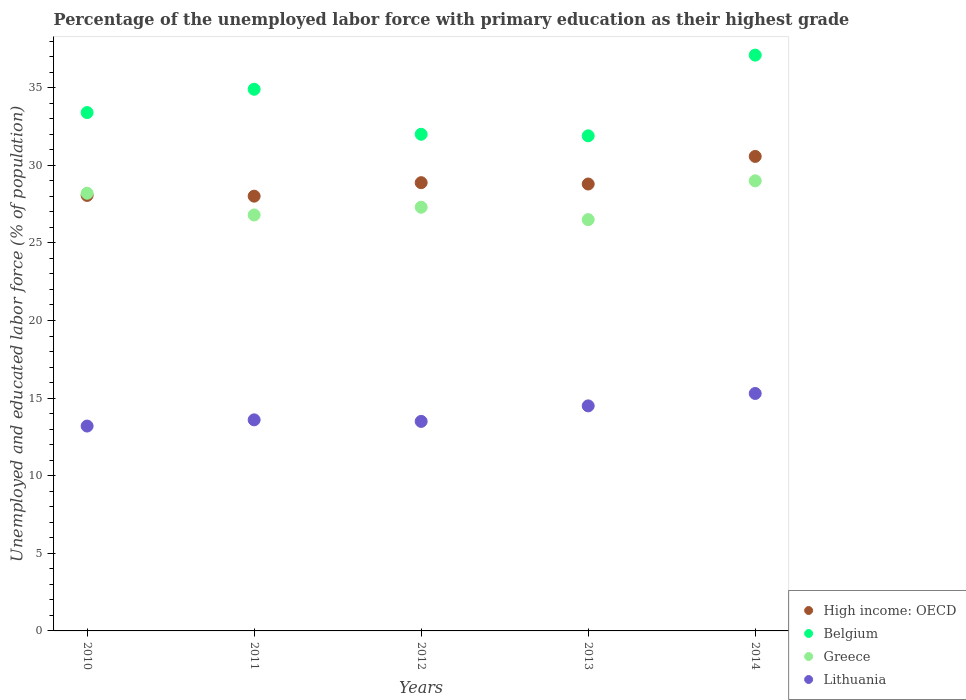What is the percentage of the unemployed labor force with primary education in Lithuania in 2010?
Make the answer very short. 13.2. Across all years, what is the maximum percentage of the unemployed labor force with primary education in Lithuania?
Your answer should be very brief. 15.3. Across all years, what is the minimum percentage of the unemployed labor force with primary education in Belgium?
Ensure brevity in your answer.  31.9. What is the total percentage of the unemployed labor force with primary education in Belgium in the graph?
Provide a short and direct response. 169.3. What is the difference between the percentage of the unemployed labor force with primary education in Greece in 2012 and the percentage of the unemployed labor force with primary education in Lithuania in 2010?
Provide a short and direct response. 14.1. What is the average percentage of the unemployed labor force with primary education in Lithuania per year?
Your response must be concise. 14.02. In the year 2011, what is the difference between the percentage of the unemployed labor force with primary education in Lithuania and percentage of the unemployed labor force with primary education in High income: OECD?
Give a very brief answer. -14.41. What is the ratio of the percentage of the unemployed labor force with primary education in Greece in 2010 to that in 2013?
Keep it short and to the point. 1.06. Is the percentage of the unemployed labor force with primary education in High income: OECD in 2012 less than that in 2013?
Ensure brevity in your answer.  No. What is the difference between the highest and the second highest percentage of the unemployed labor force with primary education in Lithuania?
Provide a succinct answer. 0.8. What is the difference between the highest and the lowest percentage of the unemployed labor force with primary education in Belgium?
Make the answer very short. 5.2. Is it the case that in every year, the sum of the percentage of the unemployed labor force with primary education in High income: OECD and percentage of the unemployed labor force with primary education in Lithuania  is greater than the sum of percentage of the unemployed labor force with primary education in Greece and percentage of the unemployed labor force with primary education in Belgium?
Make the answer very short. No. Is the percentage of the unemployed labor force with primary education in Greece strictly greater than the percentage of the unemployed labor force with primary education in High income: OECD over the years?
Make the answer very short. No. Is the percentage of the unemployed labor force with primary education in Lithuania strictly less than the percentage of the unemployed labor force with primary education in Greece over the years?
Provide a succinct answer. Yes. How many dotlines are there?
Keep it short and to the point. 4. How many years are there in the graph?
Ensure brevity in your answer.  5. Are the values on the major ticks of Y-axis written in scientific E-notation?
Your response must be concise. No. Does the graph contain any zero values?
Your response must be concise. No. Does the graph contain grids?
Keep it short and to the point. No. Where does the legend appear in the graph?
Make the answer very short. Bottom right. How are the legend labels stacked?
Offer a very short reply. Vertical. What is the title of the graph?
Offer a terse response. Percentage of the unemployed labor force with primary education as their highest grade. Does "Bangladesh" appear as one of the legend labels in the graph?
Give a very brief answer. No. What is the label or title of the X-axis?
Offer a very short reply. Years. What is the label or title of the Y-axis?
Offer a very short reply. Unemployed and educated labor force (% of population). What is the Unemployed and educated labor force (% of population) in High income: OECD in 2010?
Ensure brevity in your answer.  28.06. What is the Unemployed and educated labor force (% of population) of Belgium in 2010?
Offer a very short reply. 33.4. What is the Unemployed and educated labor force (% of population) of Greece in 2010?
Make the answer very short. 28.2. What is the Unemployed and educated labor force (% of population) in Lithuania in 2010?
Offer a very short reply. 13.2. What is the Unemployed and educated labor force (% of population) in High income: OECD in 2011?
Your answer should be compact. 28.01. What is the Unemployed and educated labor force (% of population) of Belgium in 2011?
Give a very brief answer. 34.9. What is the Unemployed and educated labor force (% of population) in Greece in 2011?
Give a very brief answer. 26.8. What is the Unemployed and educated labor force (% of population) of Lithuania in 2011?
Make the answer very short. 13.6. What is the Unemployed and educated labor force (% of population) in High income: OECD in 2012?
Give a very brief answer. 28.88. What is the Unemployed and educated labor force (% of population) in Greece in 2012?
Give a very brief answer. 27.3. What is the Unemployed and educated labor force (% of population) of Lithuania in 2012?
Offer a terse response. 13.5. What is the Unemployed and educated labor force (% of population) of High income: OECD in 2013?
Make the answer very short. 28.8. What is the Unemployed and educated labor force (% of population) in Belgium in 2013?
Your answer should be very brief. 31.9. What is the Unemployed and educated labor force (% of population) of Greece in 2013?
Your answer should be very brief. 26.5. What is the Unemployed and educated labor force (% of population) of High income: OECD in 2014?
Provide a short and direct response. 30.57. What is the Unemployed and educated labor force (% of population) of Belgium in 2014?
Ensure brevity in your answer.  37.1. What is the Unemployed and educated labor force (% of population) in Greece in 2014?
Your answer should be very brief. 29. What is the Unemployed and educated labor force (% of population) in Lithuania in 2014?
Ensure brevity in your answer.  15.3. Across all years, what is the maximum Unemployed and educated labor force (% of population) in High income: OECD?
Your response must be concise. 30.57. Across all years, what is the maximum Unemployed and educated labor force (% of population) in Belgium?
Your answer should be very brief. 37.1. Across all years, what is the maximum Unemployed and educated labor force (% of population) of Lithuania?
Offer a terse response. 15.3. Across all years, what is the minimum Unemployed and educated labor force (% of population) of High income: OECD?
Your answer should be very brief. 28.01. Across all years, what is the minimum Unemployed and educated labor force (% of population) in Belgium?
Your answer should be compact. 31.9. Across all years, what is the minimum Unemployed and educated labor force (% of population) of Lithuania?
Keep it short and to the point. 13.2. What is the total Unemployed and educated labor force (% of population) of High income: OECD in the graph?
Make the answer very short. 144.32. What is the total Unemployed and educated labor force (% of population) of Belgium in the graph?
Offer a very short reply. 169.3. What is the total Unemployed and educated labor force (% of population) in Greece in the graph?
Offer a very short reply. 137.8. What is the total Unemployed and educated labor force (% of population) in Lithuania in the graph?
Your answer should be compact. 70.1. What is the difference between the Unemployed and educated labor force (% of population) of High income: OECD in 2010 and that in 2011?
Make the answer very short. 0.05. What is the difference between the Unemployed and educated labor force (% of population) of Belgium in 2010 and that in 2011?
Offer a very short reply. -1.5. What is the difference between the Unemployed and educated labor force (% of population) of Greece in 2010 and that in 2011?
Your answer should be very brief. 1.4. What is the difference between the Unemployed and educated labor force (% of population) in Lithuania in 2010 and that in 2011?
Ensure brevity in your answer.  -0.4. What is the difference between the Unemployed and educated labor force (% of population) in High income: OECD in 2010 and that in 2012?
Make the answer very short. -0.82. What is the difference between the Unemployed and educated labor force (% of population) in Belgium in 2010 and that in 2012?
Provide a short and direct response. 1.4. What is the difference between the Unemployed and educated labor force (% of population) of Greece in 2010 and that in 2012?
Your answer should be very brief. 0.9. What is the difference between the Unemployed and educated labor force (% of population) in Lithuania in 2010 and that in 2012?
Offer a very short reply. -0.3. What is the difference between the Unemployed and educated labor force (% of population) in High income: OECD in 2010 and that in 2013?
Offer a very short reply. -0.74. What is the difference between the Unemployed and educated labor force (% of population) in Belgium in 2010 and that in 2013?
Your answer should be compact. 1.5. What is the difference between the Unemployed and educated labor force (% of population) of Lithuania in 2010 and that in 2013?
Offer a very short reply. -1.3. What is the difference between the Unemployed and educated labor force (% of population) in High income: OECD in 2010 and that in 2014?
Your answer should be compact. -2.51. What is the difference between the Unemployed and educated labor force (% of population) in Belgium in 2010 and that in 2014?
Provide a short and direct response. -3.7. What is the difference between the Unemployed and educated labor force (% of population) of Greece in 2010 and that in 2014?
Keep it short and to the point. -0.8. What is the difference between the Unemployed and educated labor force (% of population) in Lithuania in 2010 and that in 2014?
Your answer should be compact. -2.1. What is the difference between the Unemployed and educated labor force (% of population) in High income: OECD in 2011 and that in 2012?
Make the answer very short. -0.87. What is the difference between the Unemployed and educated labor force (% of population) of Belgium in 2011 and that in 2012?
Your answer should be very brief. 2.9. What is the difference between the Unemployed and educated labor force (% of population) in Greece in 2011 and that in 2012?
Your answer should be very brief. -0.5. What is the difference between the Unemployed and educated labor force (% of population) of Lithuania in 2011 and that in 2012?
Offer a very short reply. 0.1. What is the difference between the Unemployed and educated labor force (% of population) of High income: OECD in 2011 and that in 2013?
Your response must be concise. -0.78. What is the difference between the Unemployed and educated labor force (% of population) of Belgium in 2011 and that in 2013?
Provide a short and direct response. 3. What is the difference between the Unemployed and educated labor force (% of population) in High income: OECD in 2011 and that in 2014?
Offer a very short reply. -2.56. What is the difference between the Unemployed and educated labor force (% of population) in Belgium in 2011 and that in 2014?
Provide a succinct answer. -2.2. What is the difference between the Unemployed and educated labor force (% of population) in Lithuania in 2011 and that in 2014?
Your answer should be very brief. -1.7. What is the difference between the Unemployed and educated labor force (% of population) of High income: OECD in 2012 and that in 2013?
Provide a short and direct response. 0.09. What is the difference between the Unemployed and educated labor force (% of population) in Belgium in 2012 and that in 2013?
Offer a very short reply. 0.1. What is the difference between the Unemployed and educated labor force (% of population) in Greece in 2012 and that in 2013?
Your answer should be compact. 0.8. What is the difference between the Unemployed and educated labor force (% of population) in High income: OECD in 2012 and that in 2014?
Provide a succinct answer. -1.69. What is the difference between the Unemployed and educated labor force (% of population) in Greece in 2012 and that in 2014?
Give a very brief answer. -1.7. What is the difference between the Unemployed and educated labor force (% of population) in High income: OECD in 2013 and that in 2014?
Offer a terse response. -1.78. What is the difference between the Unemployed and educated labor force (% of population) in Belgium in 2013 and that in 2014?
Give a very brief answer. -5.2. What is the difference between the Unemployed and educated labor force (% of population) of Lithuania in 2013 and that in 2014?
Give a very brief answer. -0.8. What is the difference between the Unemployed and educated labor force (% of population) of High income: OECD in 2010 and the Unemployed and educated labor force (% of population) of Belgium in 2011?
Offer a terse response. -6.84. What is the difference between the Unemployed and educated labor force (% of population) of High income: OECD in 2010 and the Unemployed and educated labor force (% of population) of Greece in 2011?
Offer a very short reply. 1.26. What is the difference between the Unemployed and educated labor force (% of population) of High income: OECD in 2010 and the Unemployed and educated labor force (% of population) of Lithuania in 2011?
Your answer should be compact. 14.46. What is the difference between the Unemployed and educated labor force (% of population) in Belgium in 2010 and the Unemployed and educated labor force (% of population) in Greece in 2011?
Provide a succinct answer. 6.6. What is the difference between the Unemployed and educated labor force (% of population) of Belgium in 2010 and the Unemployed and educated labor force (% of population) of Lithuania in 2011?
Provide a succinct answer. 19.8. What is the difference between the Unemployed and educated labor force (% of population) in Greece in 2010 and the Unemployed and educated labor force (% of population) in Lithuania in 2011?
Your response must be concise. 14.6. What is the difference between the Unemployed and educated labor force (% of population) of High income: OECD in 2010 and the Unemployed and educated labor force (% of population) of Belgium in 2012?
Offer a very short reply. -3.94. What is the difference between the Unemployed and educated labor force (% of population) of High income: OECD in 2010 and the Unemployed and educated labor force (% of population) of Greece in 2012?
Your answer should be very brief. 0.76. What is the difference between the Unemployed and educated labor force (% of population) in High income: OECD in 2010 and the Unemployed and educated labor force (% of population) in Lithuania in 2012?
Provide a short and direct response. 14.56. What is the difference between the Unemployed and educated labor force (% of population) in Belgium in 2010 and the Unemployed and educated labor force (% of population) in Greece in 2012?
Your response must be concise. 6.1. What is the difference between the Unemployed and educated labor force (% of population) of Belgium in 2010 and the Unemployed and educated labor force (% of population) of Lithuania in 2012?
Give a very brief answer. 19.9. What is the difference between the Unemployed and educated labor force (% of population) in Greece in 2010 and the Unemployed and educated labor force (% of population) in Lithuania in 2012?
Keep it short and to the point. 14.7. What is the difference between the Unemployed and educated labor force (% of population) of High income: OECD in 2010 and the Unemployed and educated labor force (% of population) of Belgium in 2013?
Your answer should be very brief. -3.84. What is the difference between the Unemployed and educated labor force (% of population) of High income: OECD in 2010 and the Unemployed and educated labor force (% of population) of Greece in 2013?
Your answer should be compact. 1.56. What is the difference between the Unemployed and educated labor force (% of population) in High income: OECD in 2010 and the Unemployed and educated labor force (% of population) in Lithuania in 2013?
Your answer should be compact. 13.56. What is the difference between the Unemployed and educated labor force (% of population) of Belgium in 2010 and the Unemployed and educated labor force (% of population) of Greece in 2013?
Your answer should be compact. 6.9. What is the difference between the Unemployed and educated labor force (% of population) in Belgium in 2010 and the Unemployed and educated labor force (% of population) in Lithuania in 2013?
Your response must be concise. 18.9. What is the difference between the Unemployed and educated labor force (% of population) of High income: OECD in 2010 and the Unemployed and educated labor force (% of population) of Belgium in 2014?
Your answer should be very brief. -9.04. What is the difference between the Unemployed and educated labor force (% of population) in High income: OECD in 2010 and the Unemployed and educated labor force (% of population) in Greece in 2014?
Provide a short and direct response. -0.94. What is the difference between the Unemployed and educated labor force (% of population) in High income: OECD in 2010 and the Unemployed and educated labor force (% of population) in Lithuania in 2014?
Offer a terse response. 12.76. What is the difference between the Unemployed and educated labor force (% of population) of Belgium in 2010 and the Unemployed and educated labor force (% of population) of Greece in 2014?
Offer a very short reply. 4.4. What is the difference between the Unemployed and educated labor force (% of population) of Belgium in 2010 and the Unemployed and educated labor force (% of population) of Lithuania in 2014?
Provide a succinct answer. 18.1. What is the difference between the Unemployed and educated labor force (% of population) in High income: OECD in 2011 and the Unemployed and educated labor force (% of population) in Belgium in 2012?
Your answer should be very brief. -3.99. What is the difference between the Unemployed and educated labor force (% of population) in High income: OECD in 2011 and the Unemployed and educated labor force (% of population) in Greece in 2012?
Your answer should be very brief. 0.71. What is the difference between the Unemployed and educated labor force (% of population) in High income: OECD in 2011 and the Unemployed and educated labor force (% of population) in Lithuania in 2012?
Offer a very short reply. 14.51. What is the difference between the Unemployed and educated labor force (% of population) of Belgium in 2011 and the Unemployed and educated labor force (% of population) of Greece in 2012?
Provide a short and direct response. 7.6. What is the difference between the Unemployed and educated labor force (% of population) in Belgium in 2011 and the Unemployed and educated labor force (% of population) in Lithuania in 2012?
Offer a terse response. 21.4. What is the difference between the Unemployed and educated labor force (% of population) in High income: OECD in 2011 and the Unemployed and educated labor force (% of population) in Belgium in 2013?
Provide a succinct answer. -3.89. What is the difference between the Unemployed and educated labor force (% of population) in High income: OECD in 2011 and the Unemployed and educated labor force (% of population) in Greece in 2013?
Offer a terse response. 1.51. What is the difference between the Unemployed and educated labor force (% of population) in High income: OECD in 2011 and the Unemployed and educated labor force (% of population) in Lithuania in 2013?
Make the answer very short. 13.51. What is the difference between the Unemployed and educated labor force (% of population) of Belgium in 2011 and the Unemployed and educated labor force (% of population) of Greece in 2013?
Make the answer very short. 8.4. What is the difference between the Unemployed and educated labor force (% of population) of Belgium in 2011 and the Unemployed and educated labor force (% of population) of Lithuania in 2013?
Your answer should be very brief. 20.4. What is the difference between the Unemployed and educated labor force (% of population) of High income: OECD in 2011 and the Unemployed and educated labor force (% of population) of Belgium in 2014?
Your answer should be compact. -9.09. What is the difference between the Unemployed and educated labor force (% of population) of High income: OECD in 2011 and the Unemployed and educated labor force (% of population) of Greece in 2014?
Ensure brevity in your answer.  -0.99. What is the difference between the Unemployed and educated labor force (% of population) in High income: OECD in 2011 and the Unemployed and educated labor force (% of population) in Lithuania in 2014?
Give a very brief answer. 12.71. What is the difference between the Unemployed and educated labor force (% of population) of Belgium in 2011 and the Unemployed and educated labor force (% of population) of Greece in 2014?
Offer a terse response. 5.9. What is the difference between the Unemployed and educated labor force (% of population) in Belgium in 2011 and the Unemployed and educated labor force (% of population) in Lithuania in 2014?
Offer a terse response. 19.6. What is the difference between the Unemployed and educated labor force (% of population) in Greece in 2011 and the Unemployed and educated labor force (% of population) in Lithuania in 2014?
Provide a succinct answer. 11.5. What is the difference between the Unemployed and educated labor force (% of population) in High income: OECD in 2012 and the Unemployed and educated labor force (% of population) in Belgium in 2013?
Keep it short and to the point. -3.02. What is the difference between the Unemployed and educated labor force (% of population) of High income: OECD in 2012 and the Unemployed and educated labor force (% of population) of Greece in 2013?
Provide a succinct answer. 2.38. What is the difference between the Unemployed and educated labor force (% of population) in High income: OECD in 2012 and the Unemployed and educated labor force (% of population) in Lithuania in 2013?
Ensure brevity in your answer.  14.38. What is the difference between the Unemployed and educated labor force (% of population) of Belgium in 2012 and the Unemployed and educated labor force (% of population) of Greece in 2013?
Offer a very short reply. 5.5. What is the difference between the Unemployed and educated labor force (% of population) in High income: OECD in 2012 and the Unemployed and educated labor force (% of population) in Belgium in 2014?
Provide a short and direct response. -8.22. What is the difference between the Unemployed and educated labor force (% of population) in High income: OECD in 2012 and the Unemployed and educated labor force (% of population) in Greece in 2014?
Give a very brief answer. -0.12. What is the difference between the Unemployed and educated labor force (% of population) of High income: OECD in 2012 and the Unemployed and educated labor force (% of population) of Lithuania in 2014?
Make the answer very short. 13.58. What is the difference between the Unemployed and educated labor force (% of population) of Belgium in 2012 and the Unemployed and educated labor force (% of population) of Greece in 2014?
Offer a very short reply. 3. What is the difference between the Unemployed and educated labor force (% of population) in High income: OECD in 2013 and the Unemployed and educated labor force (% of population) in Belgium in 2014?
Keep it short and to the point. -8.3. What is the difference between the Unemployed and educated labor force (% of population) in High income: OECD in 2013 and the Unemployed and educated labor force (% of population) in Greece in 2014?
Give a very brief answer. -0.2. What is the difference between the Unemployed and educated labor force (% of population) in High income: OECD in 2013 and the Unemployed and educated labor force (% of population) in Lithuania in 2014?
Provide a succinct answer. 13.5. What is the difference between the Unemployed and educated labor force (% of population) of Belgium in 2013 and the Unemployed and educated labor force (% of population) of Greece in 2014?
Offer a very short reply. 2.9. What is the difference between the Unemployed and educated labor force (% of population) of Belgium in 2013 and the Unemployed and educated labor force (% of population) of Lithuania in 2014?
Ensure brevity in your answer.  16.6. What is the average Unemployed and educated labor force (% of population) of High income: OECD per year?
Keep it short and to the point. 28.86. What is the average Unemployed and educated labor force (% of population) of Belgium per year?
Your answer should be compact. 33.86. What is the average Unemployed and educated labor force (% of population) of Greece per year?
Offer a very short reply. 27.56. What is the average Unemployed and educated labor force (% of population) in Lithuania per year?
Keep it short and to the point. 14.02. In the year 2010, what is the difference between the Unemployed and educated labor force (% of population) in High income: OECD and Unemployed and educated labor force (% of population) in Belgium?
Make the answer very short. -5.34. In the year 2010, what is the difference between the Unemployed and educated labor force (% of population) of High income: OECD and Unemployed and educated labor force (% of population) of Greece?
Provide a short and direct response. -0.14. In the year 2010, what is the difference between the Unemployed and educated labor force (% of population) of High income: OECD and Unemployed and educated labor force (% of population) of Lithuania?
Make the answer very short. 14.86. In the year 2010, what is the difference between the Unemployed and educated labor force (% of population) in Belgium and Unemployed and educated labor force (% of population) in Greece?
Provide a short and direct response. 5.2. In the year 2010, what is the difference between the Unemployed and educated labor force (% of population) in Belgium and Unemployed and educated labor force (% of population) in Lithuania?
Keep it short and to the point. 20.2. In the year 2010, what is the difference between the Unemployed and educated labor force (% of population) of Greece and Unemployed and educated labor force (% of population) of Lithuania?
Provide a short and direct response. 15. In the year 2011, what is the difference between the Unemployed and educated labor force (% of population) in High income: OECD and Unemployed and educated labor force (% of population) in Belgium?
Offer a terse response. -6.89. In the year 2011, what is the difference between the Unemployed and educated labor force (% of population) of High income: OECD and Unemployed and educated labor force (% of population) of Greece?
Offer a very short reply. 1.21. In the year 2011, what is the difference between the Unemployed and educated labor force (% of population) of High income: OECD and Unemployed and educated labor force (% of population) of Lithuania?
Offer a terse response. 14.41. In the year 2011, what is the difference between the Unemployed and educated labor force (% of population) of Belgium and Unemployed and educated labor force (% of population) of Lithuania?
Your answer should be compact. 21.3. In the year 2011, what is the difference between the Unemployed and educated labor force (% of population) in Greece and Unemployed and educated labor force (% of population) in Lithuania?
Your response must be concise. 13.2. In the year 2012, what is the difference between the Unemployed and educated labor force (% of population) in High income: OECD and Unemployed and educated labor force (% of population) in Belgium?
Ensure brevity in your answer.  -3.12. In the year 2012, what is the difference between the Unemployed and educated labor force (% of population) in High income: OECD and Unemployed and educated labor force (% of population) in Greece?
Your response must be concise. 1.58. In the year 2012, what is the difference between the Unemployed and educated labor force (% of population) of High income: OECD and Unemployed and educated labor force (% of population) of Lithuania?
Your answer should be compact. 15.38. In the year 2012, what is the difference between the Unemployed and educated labor force (% of population) of Belgium and Unemployed and educated labor force (% of population) of Greece?
Ensure brevity in your answer.  4.7. In the year 2012, what is the difference between the Unemployed and educated labor force (% of population) in Belgium and Unemployed and educated labor force (% of population) in Lithuania?
Offer a very short reply. 18.5. In the year 2012, what is the difference between the Unemployed and educated labor force (% of population) in Greece and Unemployed and educated labor force (% of population) in Lithuania?
Provide a succinct answer. 13.8. In the year 2013, what is the difference between the Unemployed and educated labor force (% of population) of High income: OECD and Unemployed and educated labor force (% of population) of Belgium?
Offer a terse response. -3.1. In the year 2013, what is the difference between the Unemployed and educated labor force (% of population) in High income: OECD and Unemployed and educated labor force (% of population) in Greece?
Your response must be concise. 2.3. In the year 2013, what is the difference between the Unemployed and educated labor force (% of population) in High income: OECD and Unemployed and educated labor force (% of population) in Lithuania?
Provide a succinct answer. 14.3. In the year 2013, what is the difference between the Unemployed and educated labor force (% of population) in Belgium and Unemployed and educated labor force (% of population) in Lithuania?
Keep it short and to the point. 17.4. In the year 2014, what is the difference between the Unemployed and educated labor force (% of population) of High income: OECD and Unemployed and educated labor force (% of population) of Belgium?
Make the answer very short. -6.53. In the year 2014, what is the difference between the Unemployed and educated labor force (% of population) in High income: OECD and Unemployed and educated labor force (% of population) in Greece?
Keep it short and to the point. 1.57. In the year 2014, what is the difference between the Unemployed and educated labor force (% of population) in High income: OECD and Unemployed and educated labor force (% of population) in Lithuania?
Offer a very short reply. 15.27. In the year 2014, what is the difference between the Unemployed and educated labor force (% of population) of Belgium and Unemployed and educated labor force (% of population) of Lithuania?
Give a very brief answer. 21.8. In the year 2014, what is the difference between the Unemployed and educated labor force (% of population) in Greece and Unemployed and educated labor force (% of population) in Lithuania?
Your answer should be very brief. 13.7. What is the ratio of the Unemployed and educated labor force (% of population) in High income: OECD in 2010 to that in 2011?
Offer a very short reply. 1. What is the ratio of the Unemployed and educated labor force (% of population) of Belgium in 2010 to that in 2011?
Ensure brevity in your answer.  0.96. What is the ratio of the Unemployed and educated labor force (% of population) in Greece in 2010 to that in 2011?
Ensure brevity in your answer.  1.05. What is the ratio of the Unemployed and educated labor force (% of population) in Lithuania in 2010 to that in 2011?
Your answer should be compact. 0.97. What is the ratio of the Unemployed and educated labor force (% of population) of High income: OECD in 2010 to that in 2012?
Provide a succinct answer. 0.97. What is the ratio of the Unemployed and educated labor force (% of population) of Belgium in 2010 to that in 2012?
Keep it short and to the point. 1.04. What is the ratio of the Unemployed and educated labor force (% of population) in Greece in 2010 to that in 2012?
Make the answer very short. 1.03. What is the ratio of the Unemployed and educated labor force (% of population) of Lithuania in 2010 to that in 2012?
Your answer should be very brief. 0.98. What is the ratio of the Unemployed and educated labor force (% of population) in High income: OECD in 2010 to that in 2013?
Your answer should be compact. 0.97. What is the ratio of the Unemployed and educated labor force (% of population) in Belgium in 2010 to that in 2013?
Your answer should be compact. 1.05. What is the ratio of the Unemployed and educated labor force (% of population) of Greece in 2010 to that in 2013?
Your answer should be very brief. 1.06. What is the ratio of the Unemployed and educated labor force (% of population) of Lithuania in 2010 to that in 2013?
Your answer should be compact. 0.91. What is the ratio of the Unemployed and educated labor force (% of population) of High income: OECD in 2010 to that in 2014?
Ensure brevity in your answer.  0.92. What is the ratio of the Unemployed and educated labor force (% of population) in Belgium in 2010 to that in 2014?
Provide a short and direct response. 0.9. What is the ratio of the Unemployed and educated labor force (% of population) of Greece in 2010 to that in 2014?
Your answer should be compact. 0.97. What is the ratio of the Unemployed and educated labor force (% of population) of Lithuania in 2010 to that in 2014?
Provide a short and direct response. 0.86. What is the ratio of the Unemployed and educated labor force (% of population) of High income: OECD in 2011 to that in 2012?
Provide a succinct answer. 0.97. What is the ratio of the Unemployed and educated labor force (% of population) in Belgium in 2011 to that in 2012?
Make the answer very short. 1.09. What is the ratio of the Unemployed and educated labor force (% of population) in Greece in 2011 to that in 2012?
Offer a terse response. 0.98. What is the ratio of the Unemployed and educated labor force (% of population) in Lithuania in 2011 to that in 2012?
Offer a terse response. 1.01. What is the ratio of the Unemployed and educated labor force (% of population) in High income: OECD in 2011 to that in 2013?
Offer a terse response. 0.97. What is the ratio of the Unemployed and educated labor force (% of population) in Belgium in 2011 to that in 2013?
Make the answer very short. 1.09. What is the ratio of the Unemployed and educated labor force (% of population) in Greece in 2011 to that in 2013?
Provide a succinct answer. 1.01. What is the ratio of the Unemployed and educated labor force (% of population) of Lithuania in 2011 to that in 2013?
Give a very brief answer. 0.94. What is the ratio of the Unemployed and educated labor force (% of population) in High income: OECD in 2011 to that in 2014?
Give a very brief answer. 0.92. What is the ratio of the Unemployed and educated labor force (% of population) in Belgium in 2011 to that in 2014?
Provide a succinct answer. 0.94. What is the ratio of the Unemployed and educated labor force (% of population) in Greece in 2011 to that in 2014?
Ensure brevity in your answer.  0.92. What is the ratio of the Unemployed and educated labor force (% of population) of Lithuania in 2011 to that in 2014?
Make the answer very short. 0.89. What is the ratio of the Unemployed and educated labor force (% of population) in Greece in 2012 to that in 2013?
Ensure brevity in your answer.  1.03. What is the ratio of the Unemployed and educated labor force (% of population) in Lithuania in 2012 to that in 2013?
Provide a short and direct response. 0.93. What is the ratio of the Unemployed and educated labor force (% of population) of High income: OECD in 2012 to that in 2014?
Keep it short and to the point. 0.94. What is the ratio of the Unemployed and educated labor force (% of population) of Belgium in 2012 to that in 2014?
Make the answer very short. 0.86. What is the ratio of the Unemployed and educated labor force (% of population) in Greece in 2012 to that in 2014?
Keep it short and to the point. 0.94. What is the ratio of the Unemployed and educated labor force (% of population) of Lithuania in 2012 to that in 2014?
Provide a succinct answer. 0.88. What is the ratio of the Unemployed and educated labor force (% of population) of High income: OECD in 2013 to that in 2014?
Your answer should be very brief. 0.94. What is the ratio of the Unemployed and educated labor force (% of population) of Belgium in 2013 to that in 2014?
Give a very brief answer. 0.86. What is the ratio of the Unemployed and educated labor force (% of population) of Greece in 2013 to that in 2014?
Provide a short and direct response. 0.91. What is the ratio of the Unemployed and educated labor force (% of population) in Lithuania in 2013 to that in 2014?
Your answer should be very brief. 0.95. What is the difference between the highest and the second highest Unemployed and educated labor force (% of population) of High income: OECD?
Your answer should be very brief. 1.69. What is the difference between the highest and the second highest Unemployed and educated labor force (% of population) of Belgium?
Keep it short and to the point. 2.2. What is the difference between the highest and the second highest Unemployed and educated labor force (% of population) in Lithuania?
Your answer should be very brief. 0.8. What is the difference between the highest and the lowest Unemployed and educated labor force (% of population) in High income: OECD?
Provide a short and direct response. 2.56. What is the difference between the highest and the lowest Unemployed and educated labor force (% of population) in Belgium?
Make the answer very short. 5.2. 